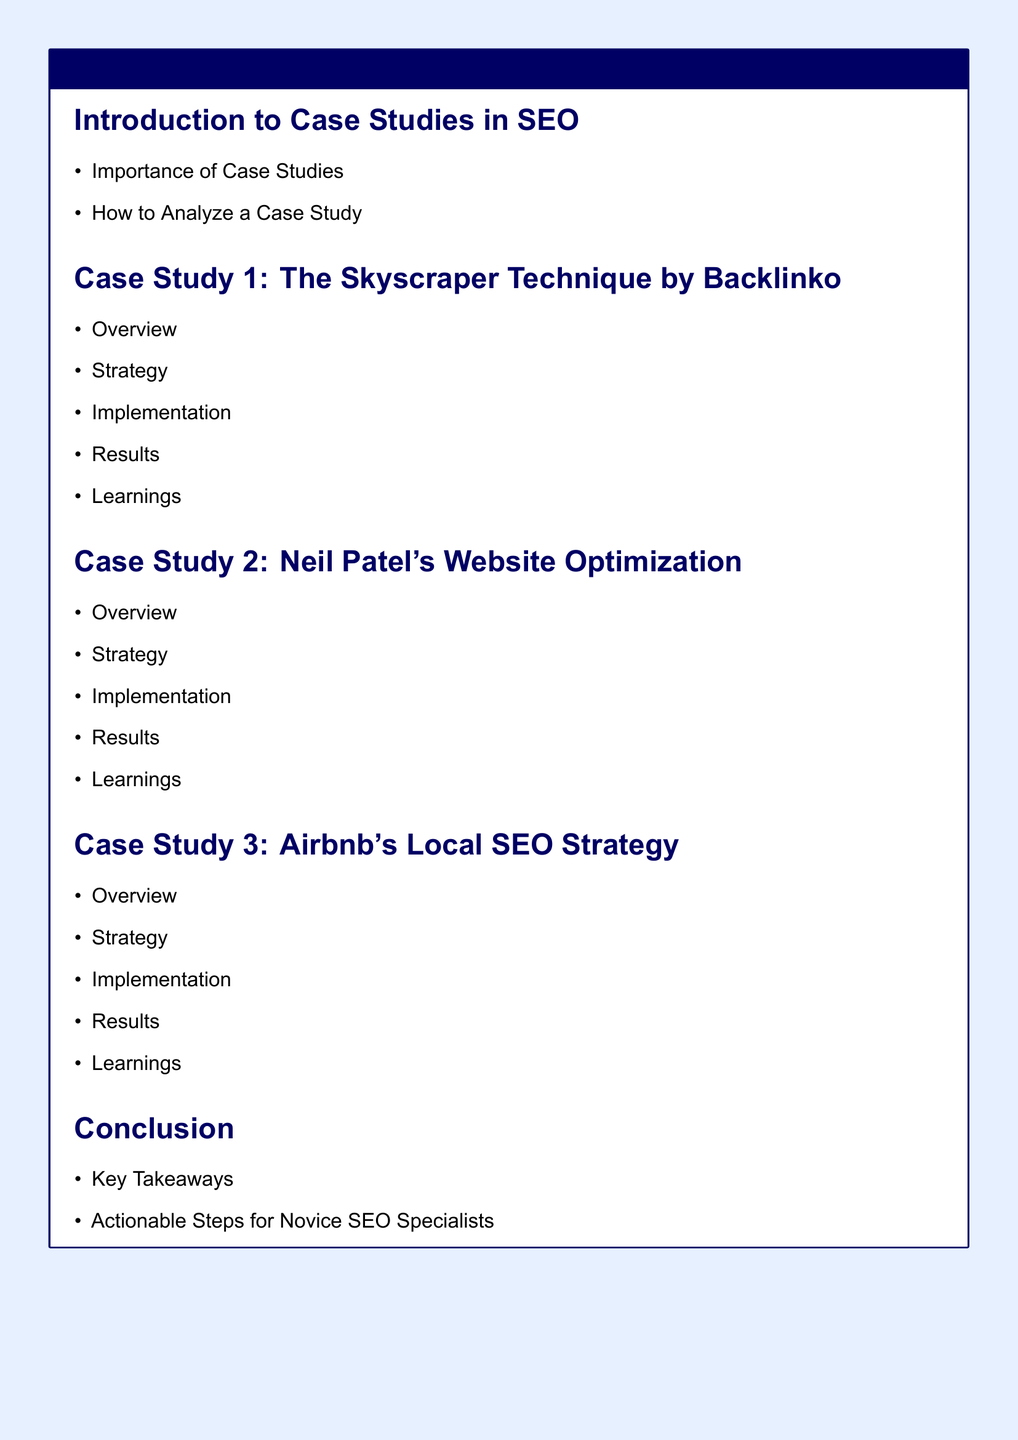What is the title of the document? The title of the document is specified in the tcolorbox as "Case Studies of Successful SEO Strategies."
Answer: Case Studies of Successful SEO Strategies How many case studies are included in the document? The document lists three distinct case studies in the main content, as evident from the sections.
Answer: 3 Who authored the Skyscraper Technique case study? The author of the Skyscraper Technique case study is mentioned in the title of the case study as Backlinko.
Answer: Backlinko What is the focus of the third case study? The third case study specifically focuses on Airbnb's approach, indicated in the case study title.
Answer: Local SEO Strategy What are the two primary sections indicated in the Introduction to Case Studies in SEO? The introduction lists two key aspects: the importance of case studies and how to analyze a case study.
Answer: Importance of Case Studies, How to Analyze a Case Study What type of box encloses the document's title? The document's title is enclosed within a colored box, defined by the use of tcolorbox.
Answer: tcolorbox What conclusion aspect is specifically aimed at novice SEO specialists? The document states under conclusion that there are actionable steps specifically designed for novice SEO specialists.
Answer: Actionable Steps for Novice SEO Specialists What color is used for the page background in the document? The document specifies the background color of the page as light blue.
Answer: light blue 